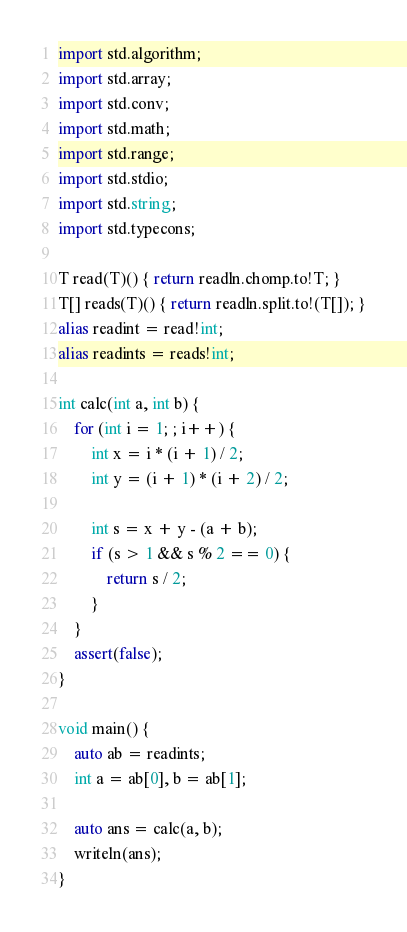Convert code to text. <code><loc_0><loc_0><loc_500><loc_500><_D_>import std.algorithm;
import std.array;
import std.conv;
import std.math;
import std.range;
import std.stdio;
import std.string;
import std.typecons;

T read(T)() { return readln.chomp.to!T; }
T[] reads(T)() { return readln.split.to!(T[]); }
alias readint = read!int;
alias readints = reads!int;

int calc(int a, int b) {
    for (int i = 1; ; i++) {
        int x = i * (i + 1) / 2;
        int y = (i + 1) * (i + 2) / 2;

        int s = x + y - (a + b);
        if (s > 1 && s % 2 == 0) {
            return s / 2;
        }
    }
    assert(false);
}

void main() {
    auto ab = readints;
    int a = ab[0], b = ab[1];

    auto ans = calc(a, b);
    writeln(ans);
}
</code> 